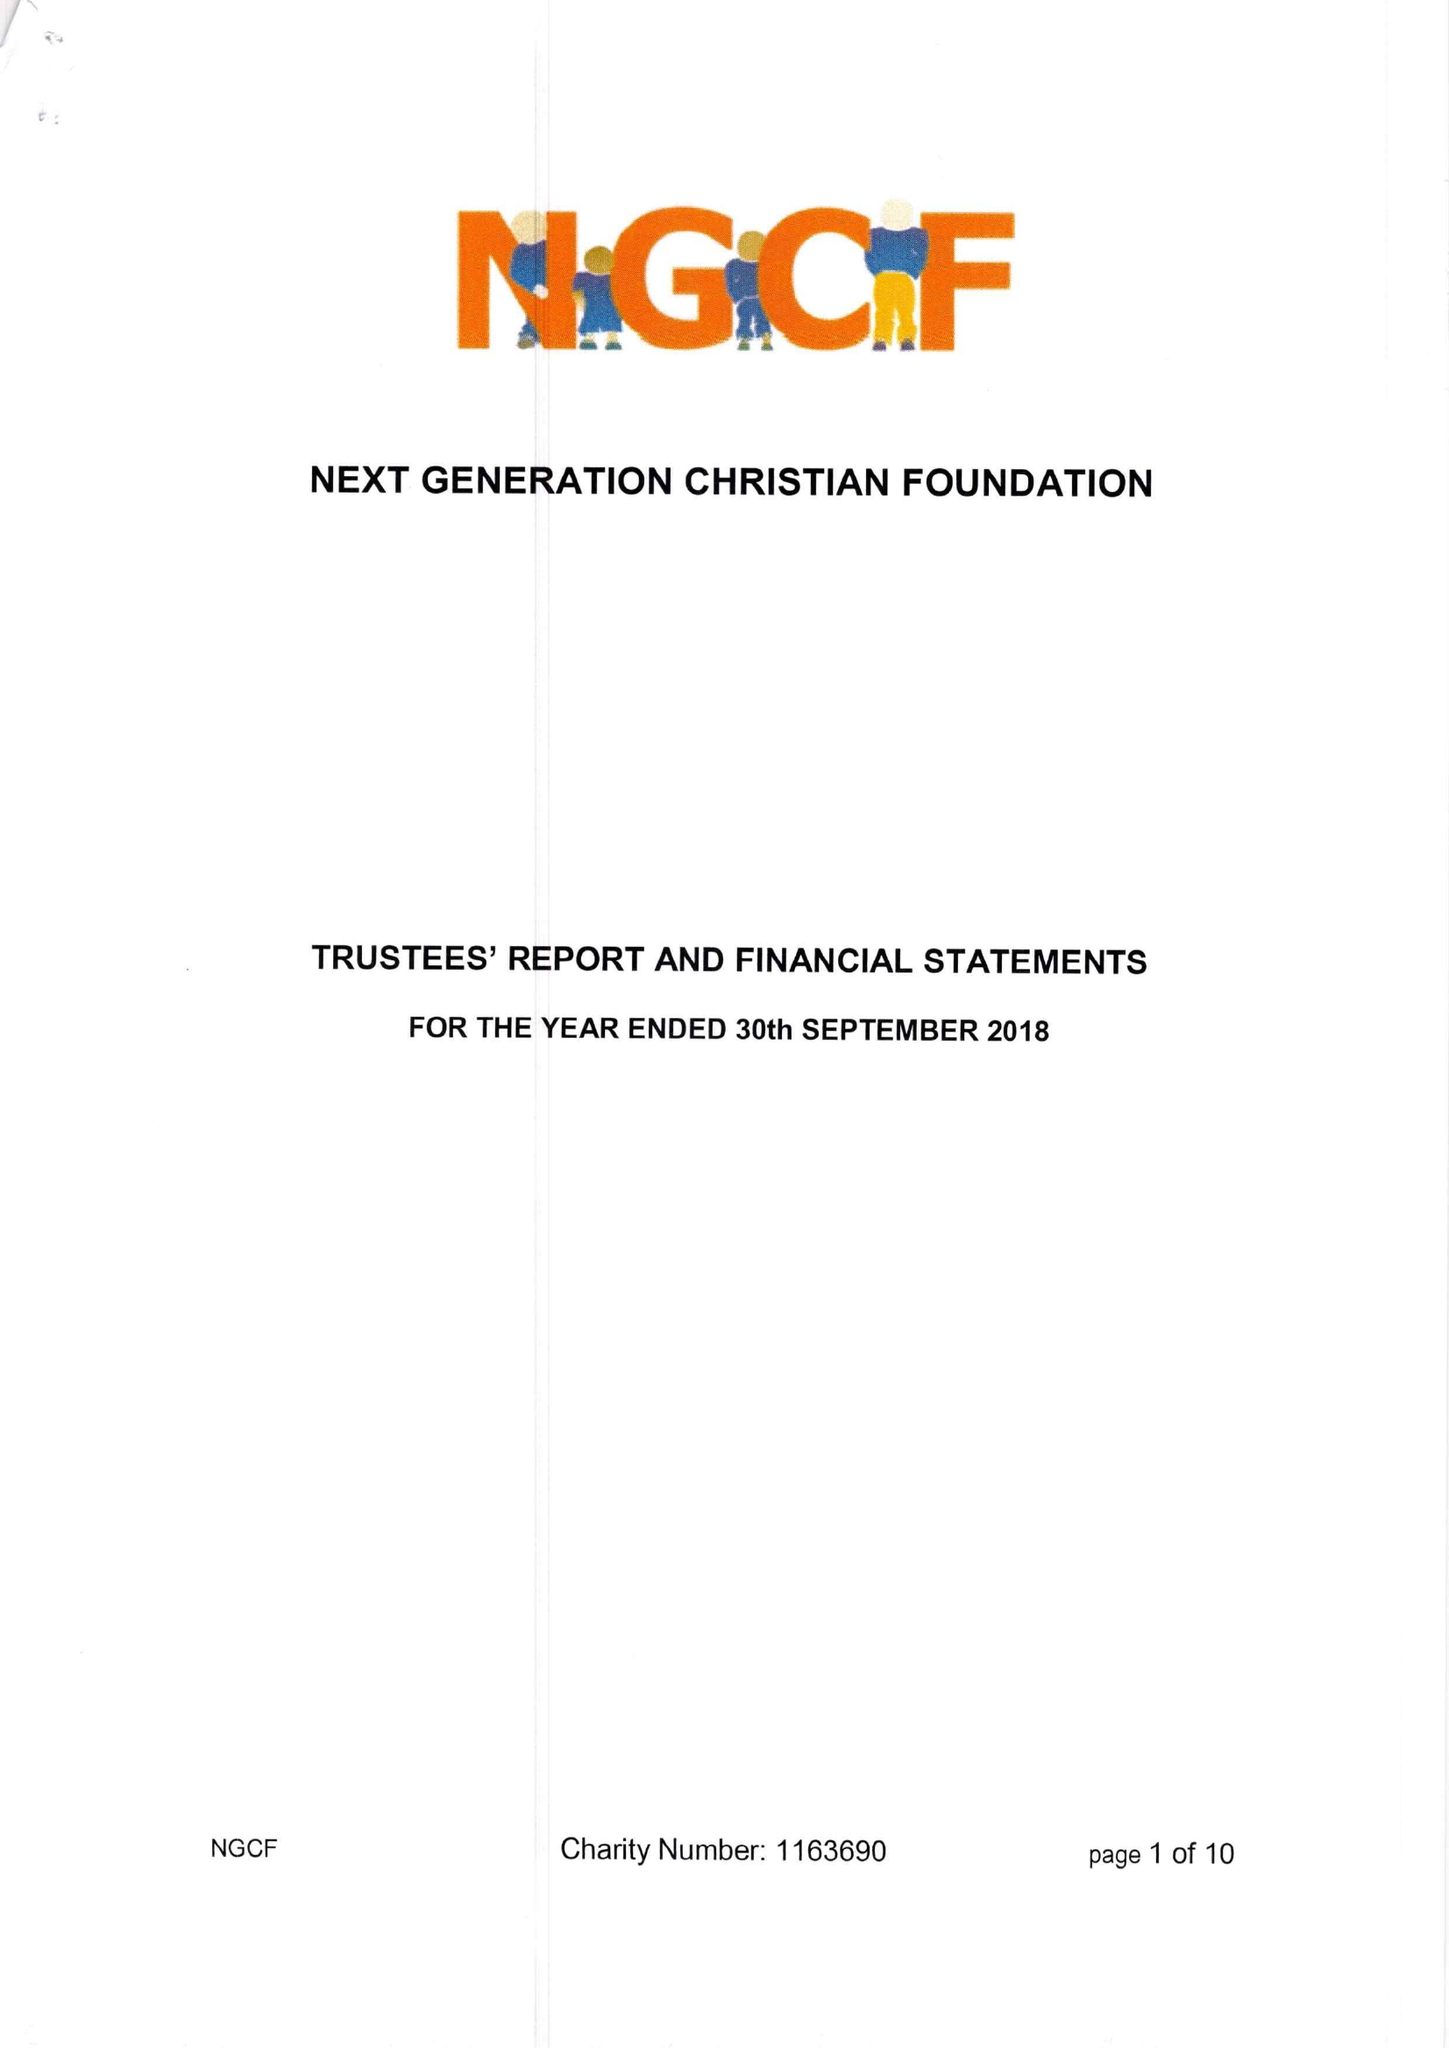What is the value for the address__postcode?
Answer the question using a single word or phrase. RG6 7DA 